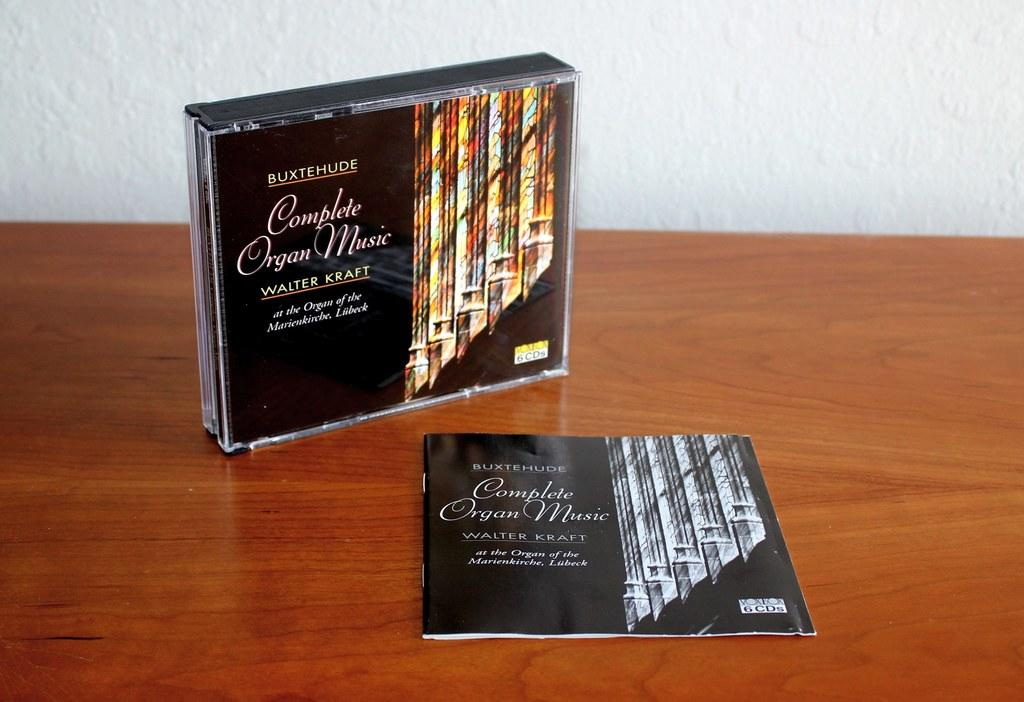<image>
Describe the image concisely. A cd case with the name Complete Organ Music on it 